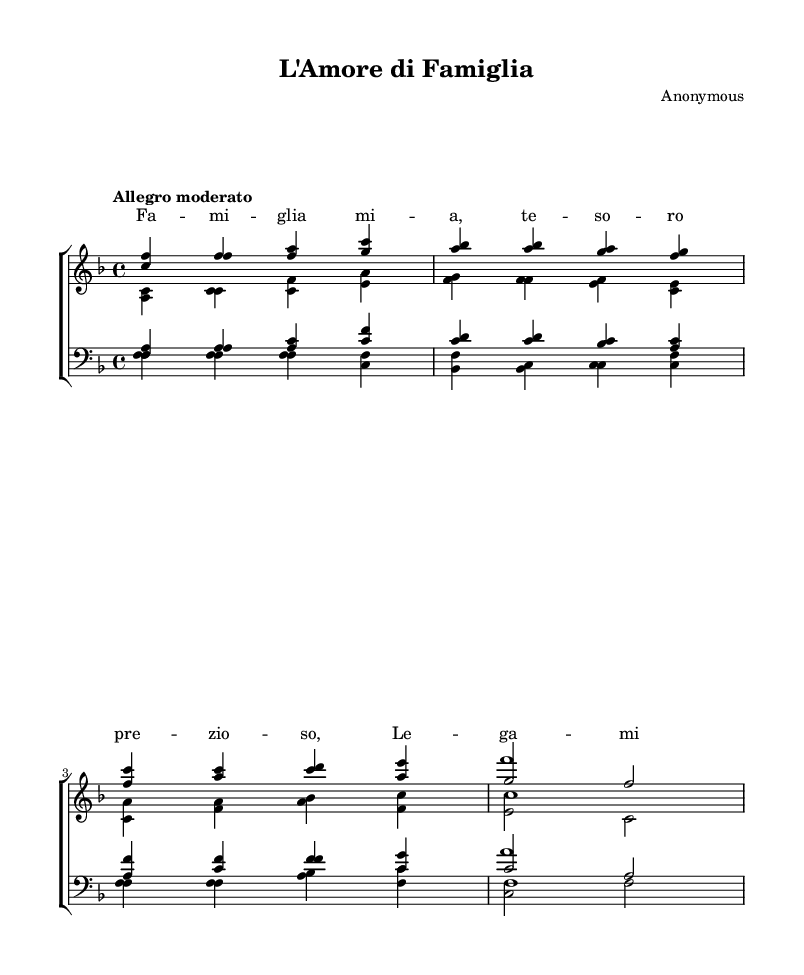What is the key signature of this music? The key signature is indicated by the markings at the beginning of the staff. In this case, there are one flat, which means the key is F major.
Answer: F major What is the time signature of this piece? The time signature is shown at the beginning of the staff, where it is specified as 4/4 time, meaning four beats per measure.
Answer: 4/4 What is the tempo marking for this piece? The tempo is given in words above the staff as "Allegro moderato," which indicates a moderately fast pace.
Answer: Allegro moderato How many voices are there in total for the women's section? The women's section has two distinct voices: sopranos and altos, making for a total of two voices.
Answer: Two What is the structure of the piece in terms of verses and choruses? The structure consists of verses sung by each part followed by a shared chorus, as indicated in the score. Each voice presents a verse and concludes with a chorus.
Answer: Verse and Chorus What is the theme of the lyrics in the chorus? The lyrics of the chorus celebrate unity and love, emphasizing family bonds and togetherness as a guiding force.
Answer: Unity and Love 